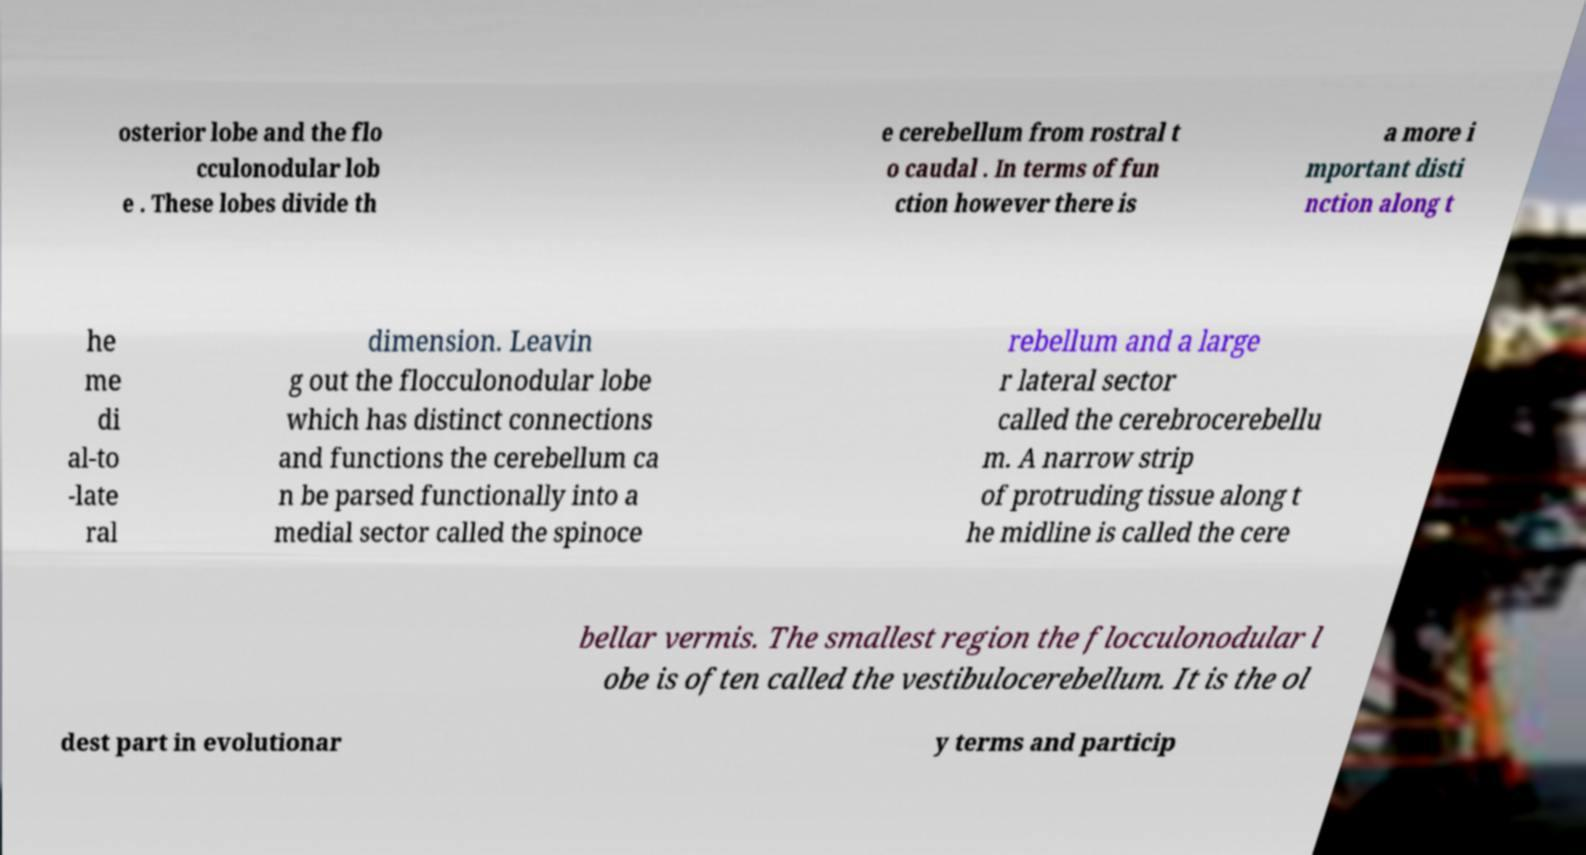What messages or text are displayed in this image? I need them in a readable, typed format. osterior lobe and the flo cculonodular lob e . These lobes divide th e cerebellum from rostral t o caudal . In terms of fun ction however there is a more i mportant disti nction along t he me di al-to -late ral dimension. Leavin g out the flocculonodular lobe which has distinct connections and functions the cerebellum ca n be parsed functionally into a medial sector called the spinoce rebellum and a large r lateral sector called the cerebrocerebellu m. A narrow strip of protruding tissue along t he midline is called the cere bellar vermis. The smallest region the flocculonodular l obe is often called the vestibulocerebellum. It is the ol dest part in evolutionar y terms and particip 